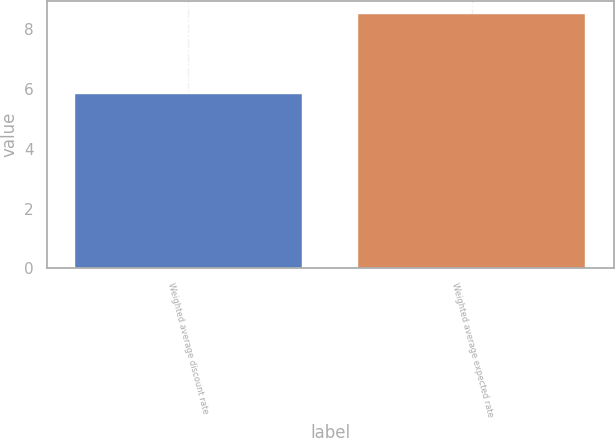Convert chart. <chart><loc_0><loc_0><loc_500><loc_500><bar_chart><fcel>Weighted average discount rate<fcel>Weighted average expected rate<nl><fcel>5.83<fcel>8.5<nl></chart> 